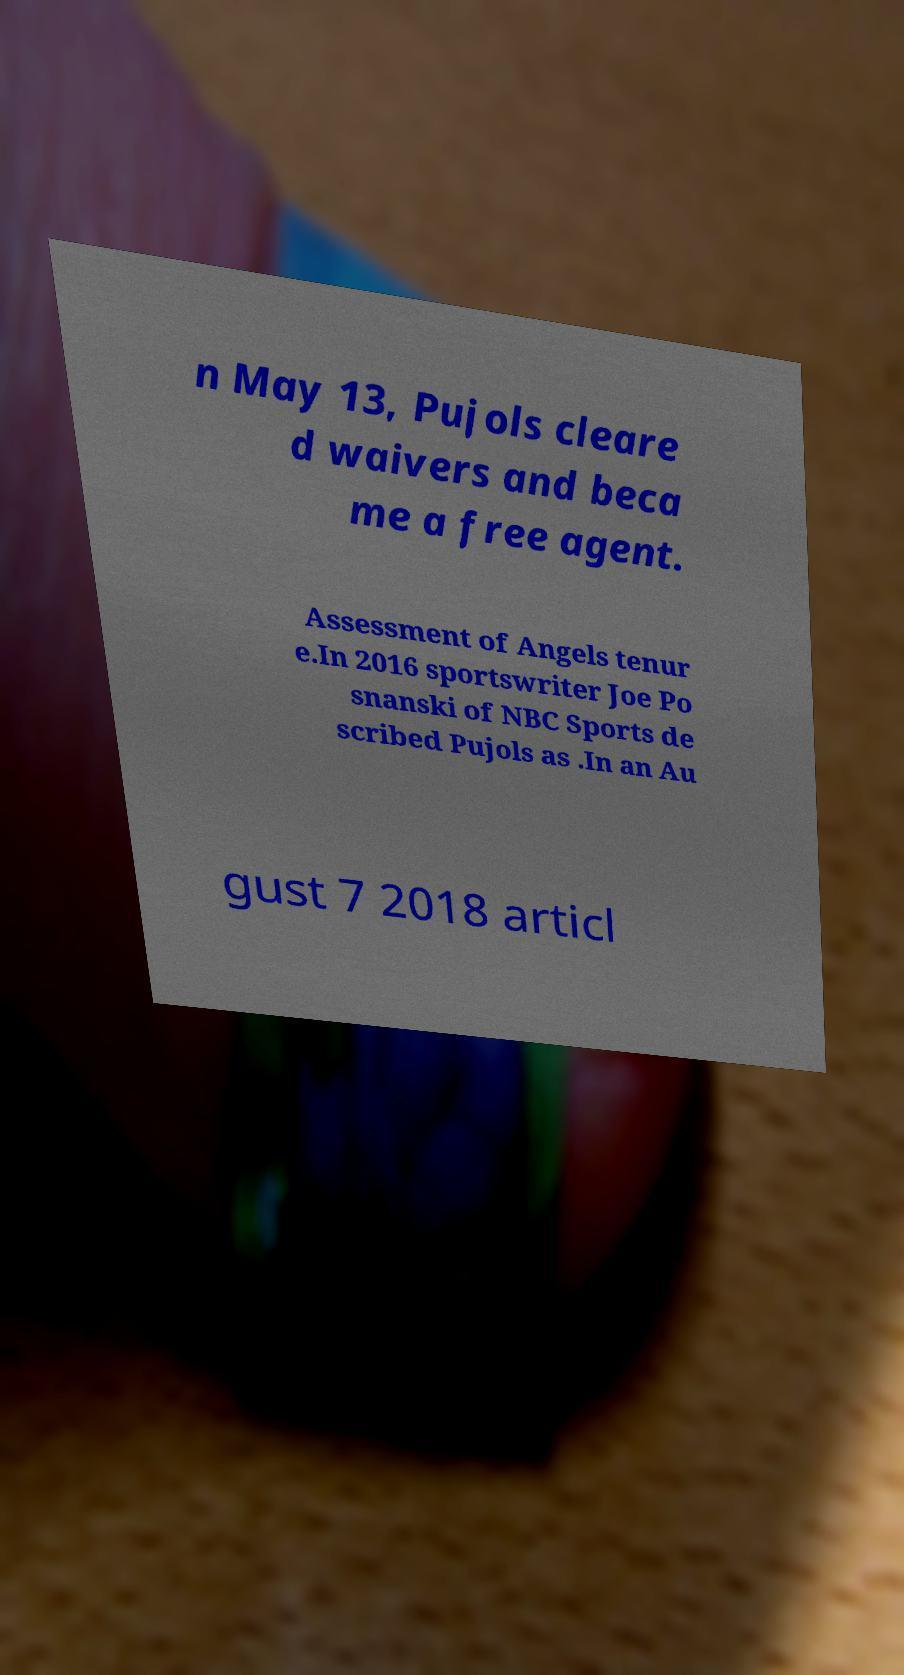I need the written content from this picture converted into text. Can you do that? n May 13, Pujols cleare d waivers and beca me a free agent. Assessment of Angels tenur e.In 2016 sportswriter Joe Po snanski of NBC Sports de scribed Pujols as .In an Au gust 7 2018 articl 